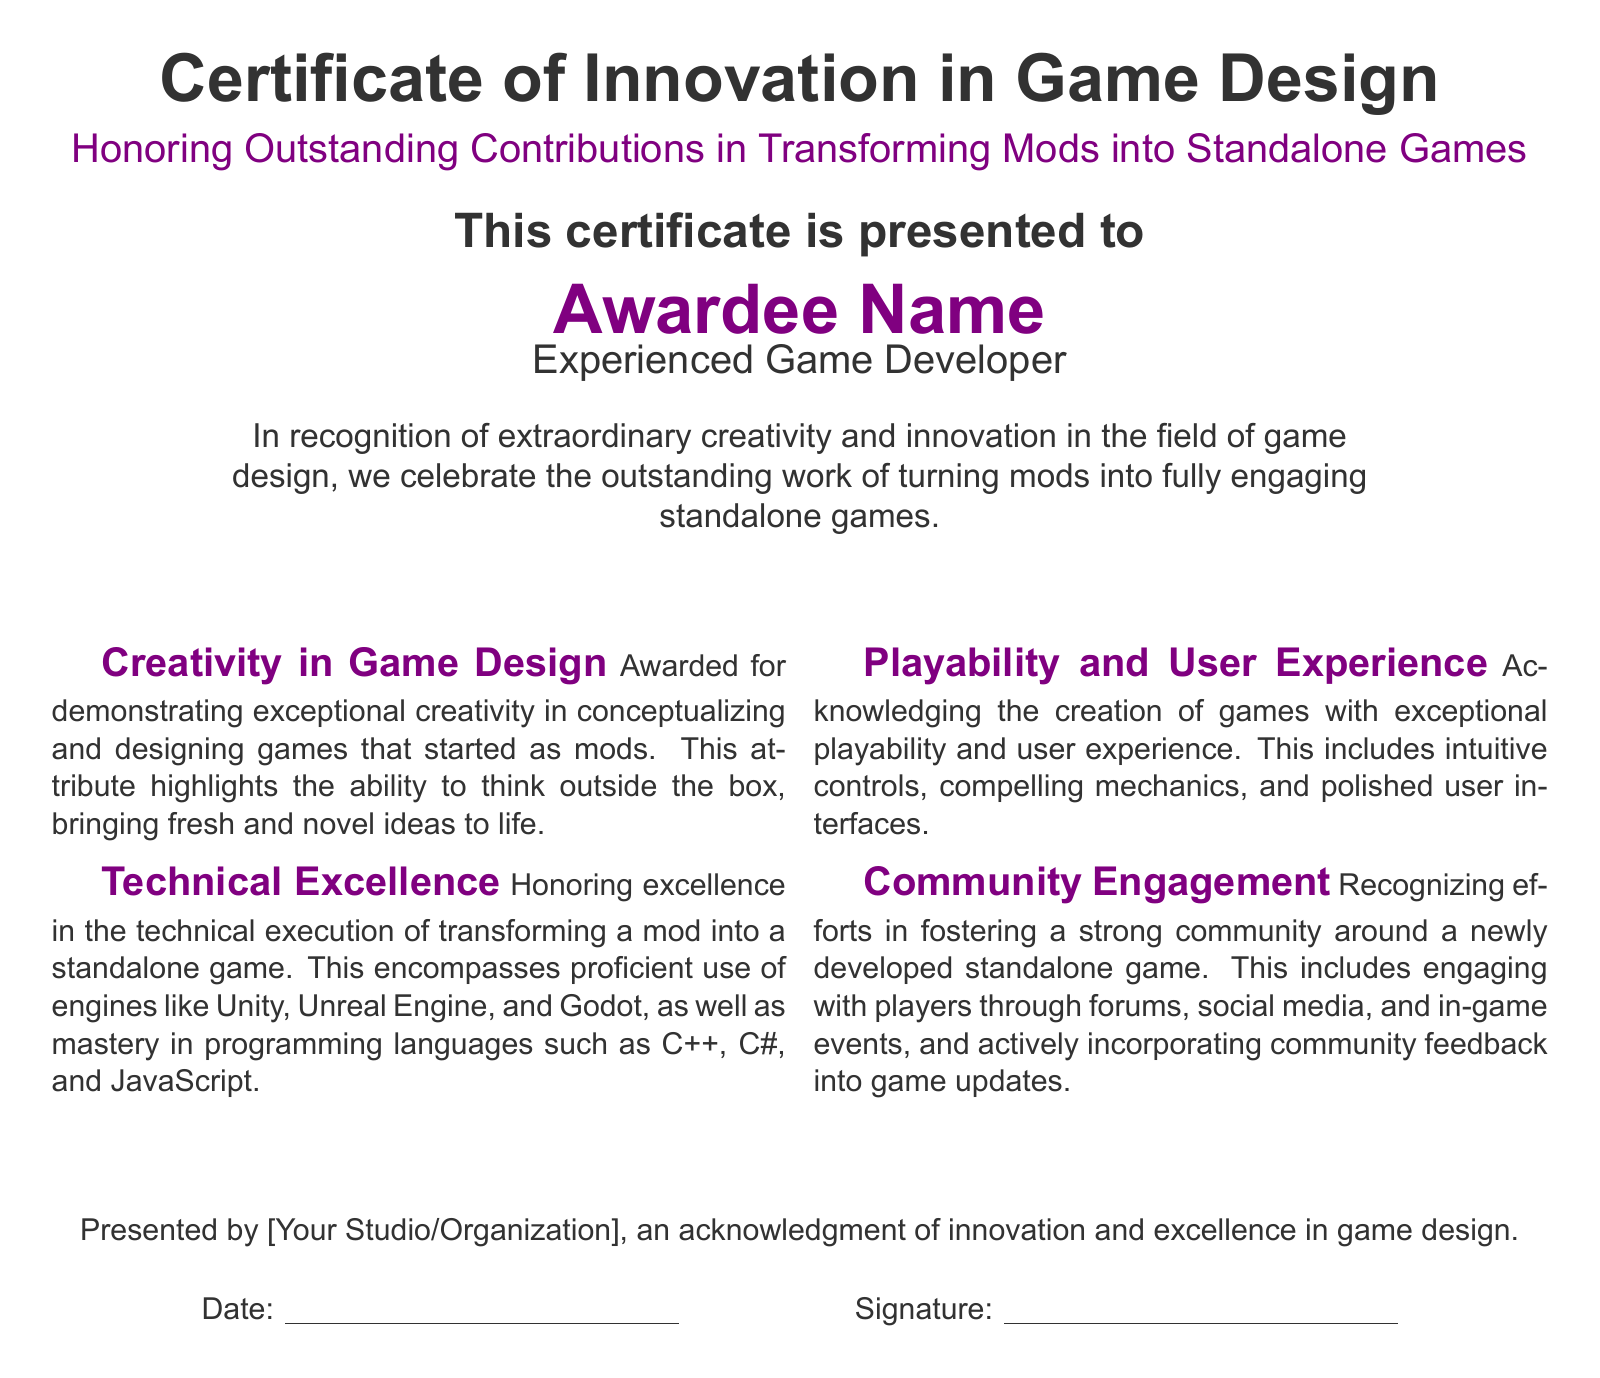What is the title of the certificate? The title of the certificate is prominently displayed at the top of the document, which is "Certificate of Innovation in Game Design."
Answer: Certificate of Innovation in Game Design Who is the certificate presented to? The document clearly states to whom the certificate is awarded, which is specified as "Awardee Name."
Answer: Awardee Name What color is used for the section titles? The document uses a specific color for section titles, which is described as "gamerpurple."
Answer: gamerpurple What is acknowledged under the "Playability and User Experience" section? This section recognizes the quality of games created, emphasizing intuitive controls and polished user interfaces.
Answer: Exceptional playability and user experience Which studio or organization presents the certificate? The certificate mentions that it is presented by a particular entity, which is indicated as "[Your Studio/Organization]."
Answer: [Your Studio/Organization] What languages are mentioned in the "Technical Excellence" section? The document lists specific programming languages within this section, including C++, C#, and JavaScript.
Answer: C++, C#, and JavaScript What does the certificate celebrate in the context of game design? The certificate honors contributions specifically in transforming mods into engaging standalone games, highlighting creativity.
Answer: Transforming mods into engaging standalone games On what date is the certificate supposed to be presented? The document includes a space for writing the date, indicating that it is an unspecified date left blank for filling in.
Answer: (blank space) 